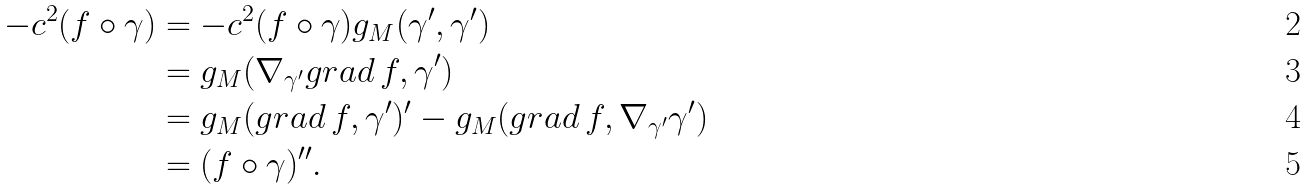<formula> <loc_0><loc_0><loc_500><loc_500>- c ^ { 2 } ( f \circ \gamma ) & = - c ^ { 2 } ( f \circ \gamma ) g _ { M } ( \gamma ^ { \prime } , \gamma ^ { \prime } ) \\ & = g _ { M } ( \nabla _ { \gamma ^ { \prime } } g r a d \, f , \gamma ^ { \prime } ) \\ & = g _ { M } ( g r a d \, f , \gamma ^ { \prime } ) ^ { \prime } - g _ { M } ( g r a d \, f , \nabla _ { \gamma ^ { \prime } } \gamma ^ { \prime } ) \\ & = ( f \circ \gamma ) ^ { \prime \prime } .</formula> 